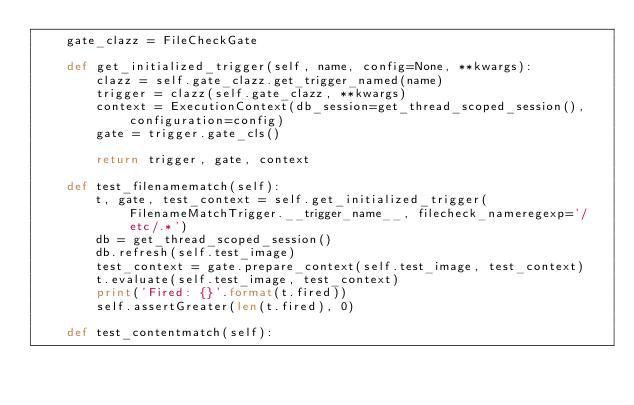<code> <loc_0><loc_0><loc_500><loc_500><_Python_>    gate_clazz = FileCheckGate

    def get_initialized_trigger(self, name, config=None, **kwargs):
        clazz = self.gate_clazz.get_trigger_named(name)
        trigger = clazz(self.gate_clazz, **kwargs)
        context = ExecutionContext(db_session=get_thread_scoped_session(), configuration=config)
        gate = trigger.gate_cls()

        return trigger, gate, context

    def test_filenamematch(self):
        t, gate, test_context = self.get_initialized_trigger(FilenameMatchTrigger.__trigger_name__, filecheck_nameregexp='/etc/.*')
        db = get_thread_scoped_session()
        db.refresh(self.test_image)
        test_context = gate.prepare_context(self.test_image, test_context)
        t.evaluate(self.test_image, test_context)
        print('Fired: {}'.format(t.fired))
        self.assertGreater(len(t.fired), 0)

    def test_contentmatch(self):</code> 